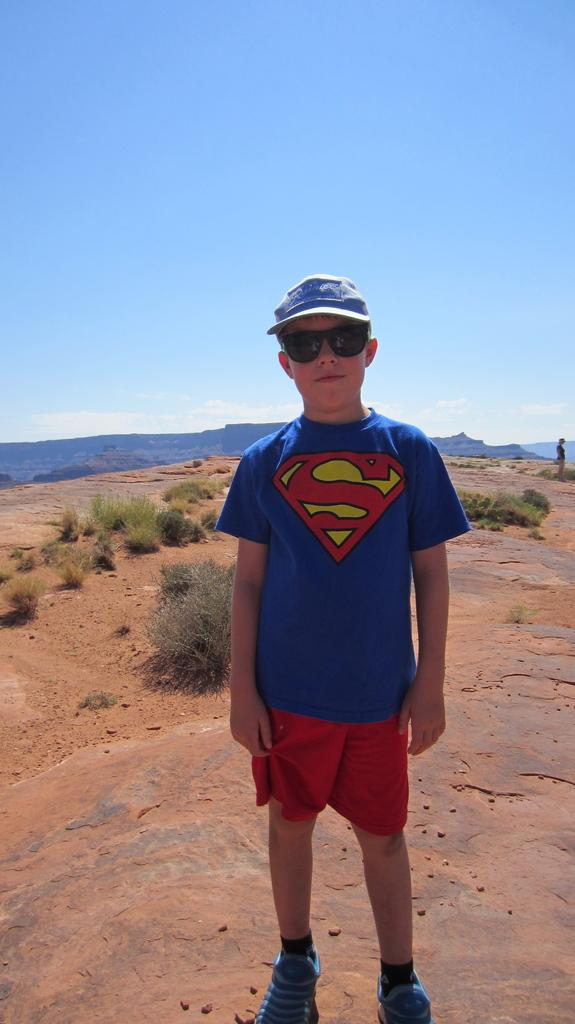What is the main subject of the picture? The main subject of the picture is a boy. What is the boy wearing on his head? The boy is wearing a cap. What type of footwear is the boy wearing? The boy is wearing shoes. What protective eyewear is the boy wearing? The boy is wearing goggles. Where is the boy standing in the picture? The boy is standing on the ground. What is the boy's facial expression in the picture? The boy is smiling. What can be seen in the background of the picture? There are plants, mountains, a person, and the sky visible in the background of the picture. What type of bread is the boy holding in the picture? There is no bread present in the picture; the boy is wearing goggles and standing on the ground. What experience does the boy have with hate in the picture? There is no indication of hate or any negative emotions in the picture, as the boy is smiling. 